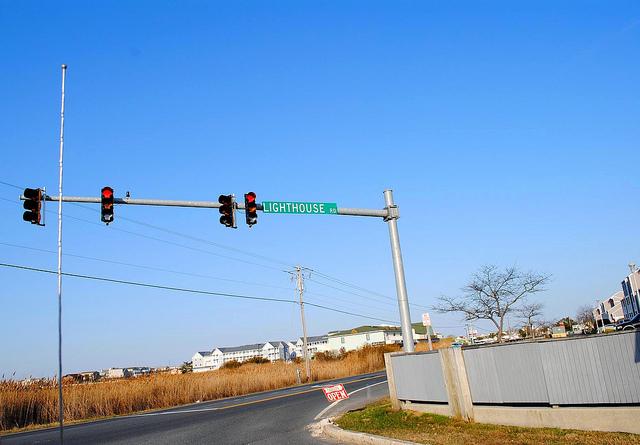Should I stop at the light or go?
Be succinct. Stop. What is the name of the road that is on the green sign?
Concise answer only. Lighthouse. Is this a black and white photo?
Write a very short answer. No. What color is the traffic light?
Short answer required. Red. Are the traffic lights facing the same direction?
Be succinct. No. 